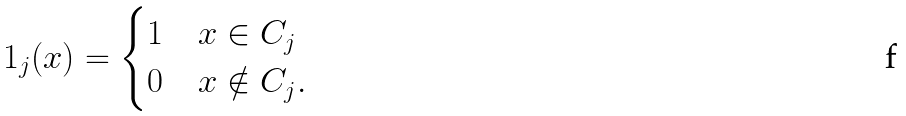<formula> <loc_0><loc_0><loc_500><loc_500>1 _ { j } ( x ) = \begin{cases} 1 & x \in C _ { j } \\ 0 & x \notin C _ { j } . \end{cases}</formula> 